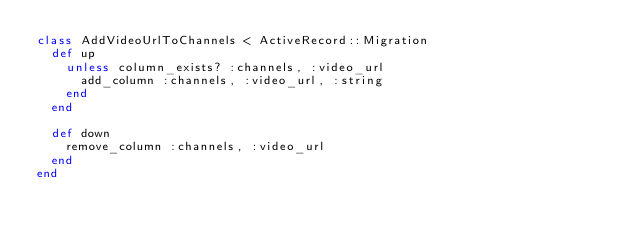<code> <loc_0><loc_0><loc_500><loc_500><_Ruby_>class AddVideoUrlToChannels < ActiveRecord::Migration
  def up
    unless column_exists? :channels, :video_url
      add_column :channels, :video_url, :string
    end
  end

  def down
    remove_column :channels, :video_url
  end
end
</code> 